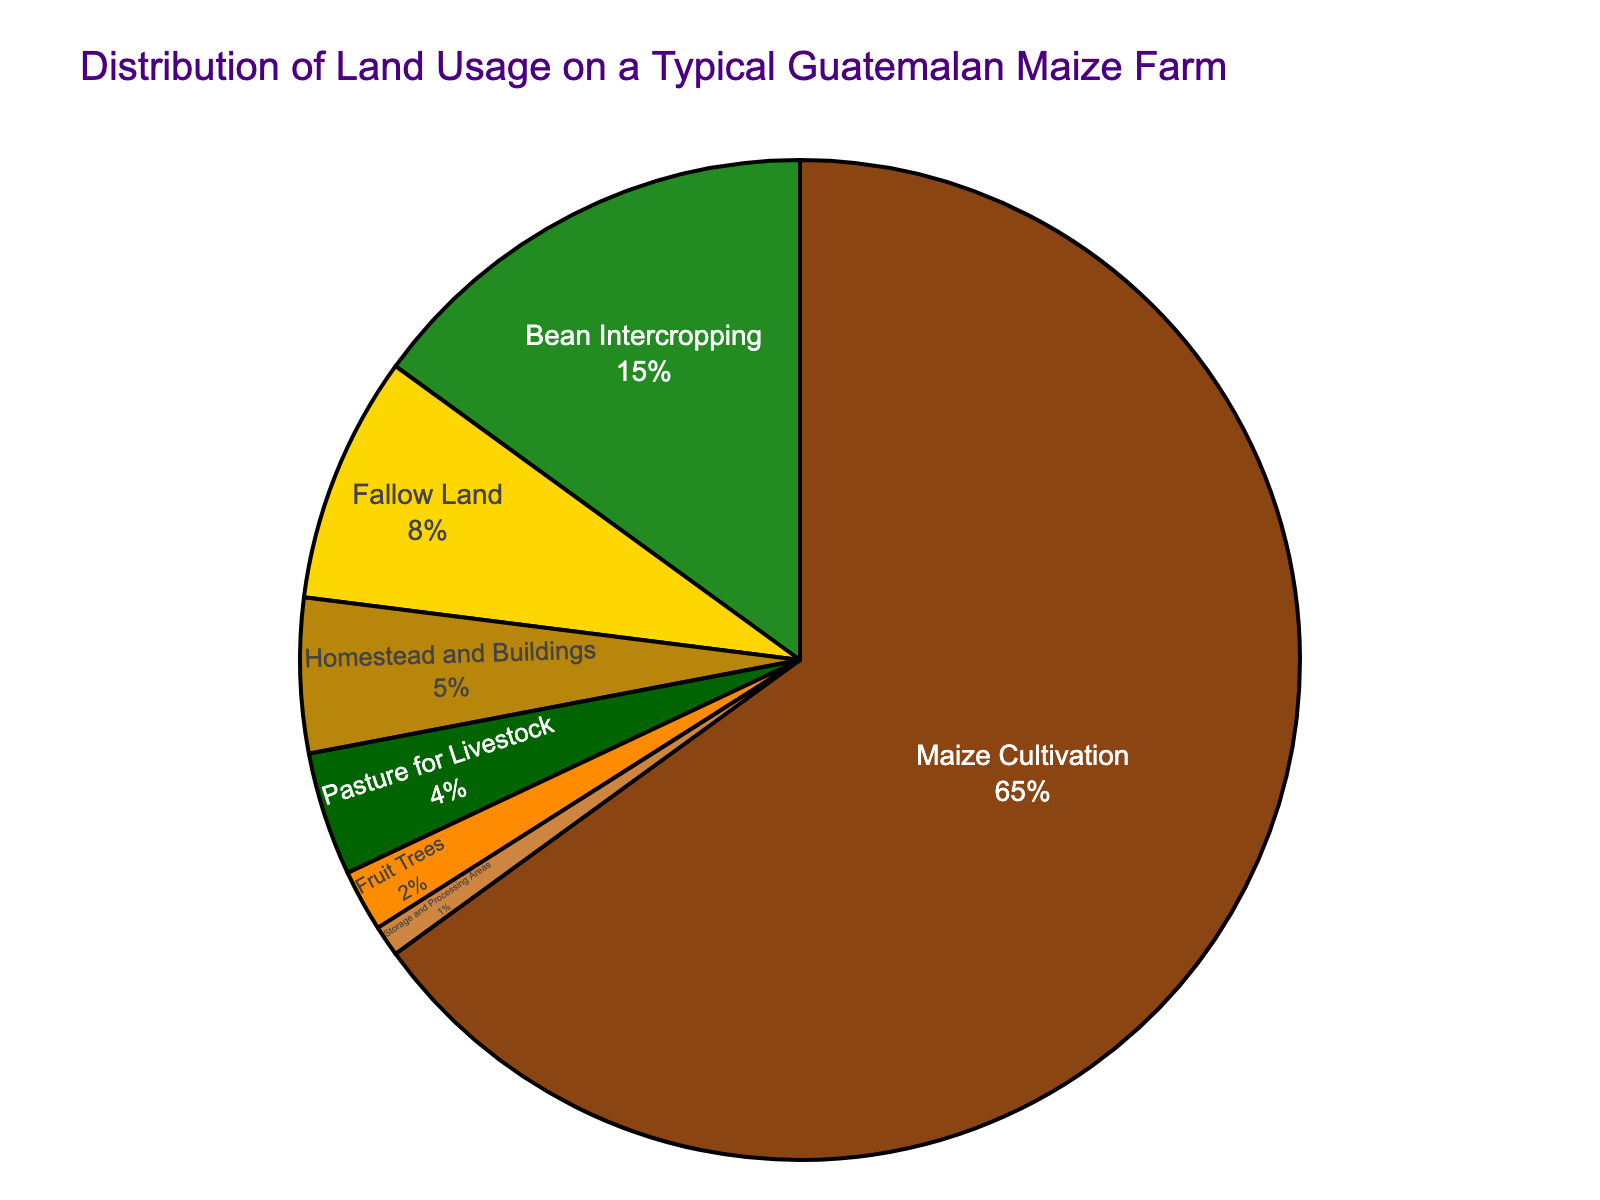What percentage of the land is used for Bean Intercropping? The pie chart shows different categories of land usage and their respective percentages. By looking at the part labeled "Bean Intercropping," we can see it is 15%.
Answer: 15% What is the combined percentage of land used for Homestead and Buildings, and Pasture for Livestock? Locate the segments labeled "Homestead and Buildings" and "Pasture for Livestock." Homestead and Buildings is 5% and Pasture for Livestock is 4%. Add these together: 5% + 4% = 9%.
Answer: 9% Which land use category has the smallest percentage? By examining the pie chart, identify the segment with the smallest area. The segment labeled "Storage and Processing Areas" is the smallest, with a percentage of 1%.
Answer: Storage and Processing Areas Is more land used for Maize Cultivation or for Maize Cultivation and Bean Intercropping combined? First note the percentage for Maize Cultivation which is 65%. Then add the percentages of Maize Cultivation (65%) and Bean Intercropping (15%): 65% + 15% = 80%. This combined value (80%) is indeed larger than the land used solely for Maize Cultivation (65%).
Answer: Maize Cultivation and Bean Intercropping combined What is the visual representation color for Fallow Land? The pie chart uses different colors for each segment. Identify the color used for the segment labeled "Fallow Land." This segment is colored yellow.
Answer: Yellow What is the difference in the percentage of land used for Fruit Trees and Pasture for Livestock? The percentage of land used for Fruit Trees is 2%, and for Pasture for Livestock, it is 4%. The difference is calculated by subtracting 2% from 4% which gives 4% - 2% = 2%.
Answer: 2% How does the percentage of land used for Maize Cultivation compare to the total percentage of land used for Bean Intercropping, Fallow Land, and Fruit Trees combined? Calculate the total percentage for Bean Intercropping (15%), Fallow Land (8%), and Fruit Trees (2%). Sum these percentages: 15% + 8% + 2% = 25%. Compare this to Maize Cultivation which is 65%. 65% is greater than 25%.
Answer: Greater What is the percentage of land not used for Maize Cultivation? Subtract the percentage used for Maize Cultivation from 100% to find the land not used for it. This is 100% - 65% = 35%.
Answer: 35% 